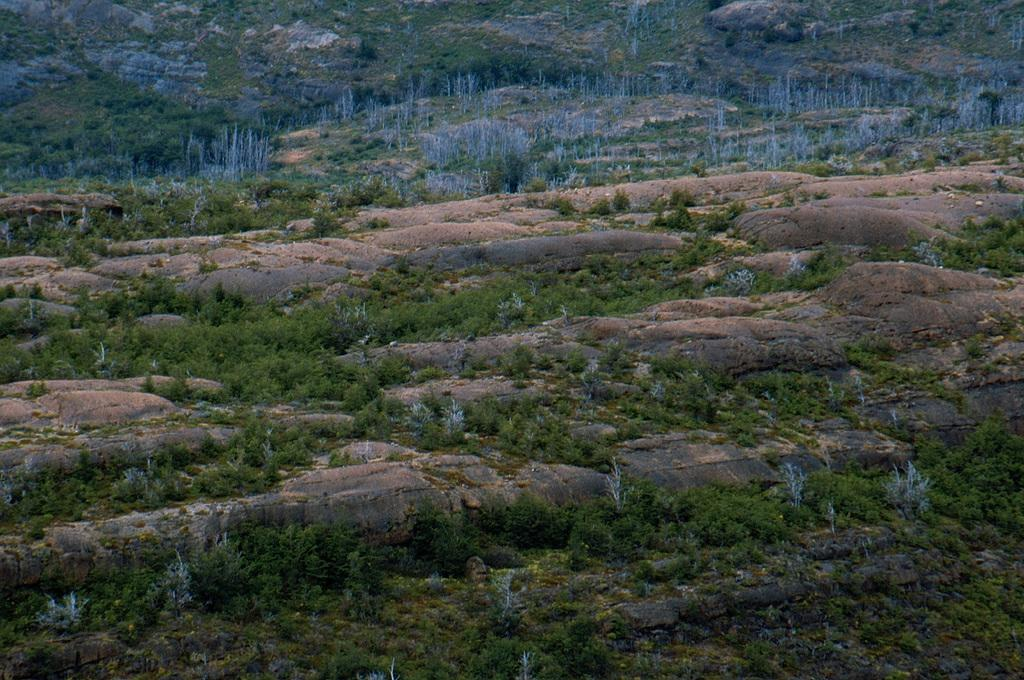What is located on the rock in the image? There are plants on a rock in the image. What can be seen at the top of the image? There are plants at the top of the image. What type of vegetation is present on the land in the image? Trees are present on the land in the image. Can you tell me how many airplanes are flying in the image? There are no airplanes present in the image; it features plants on a rock, plants at the top, and trees on the land. What type of fiction is depicted in the image? There is no fiction depicted in the image; it is a photograph of plants and trees in a natural setting. 